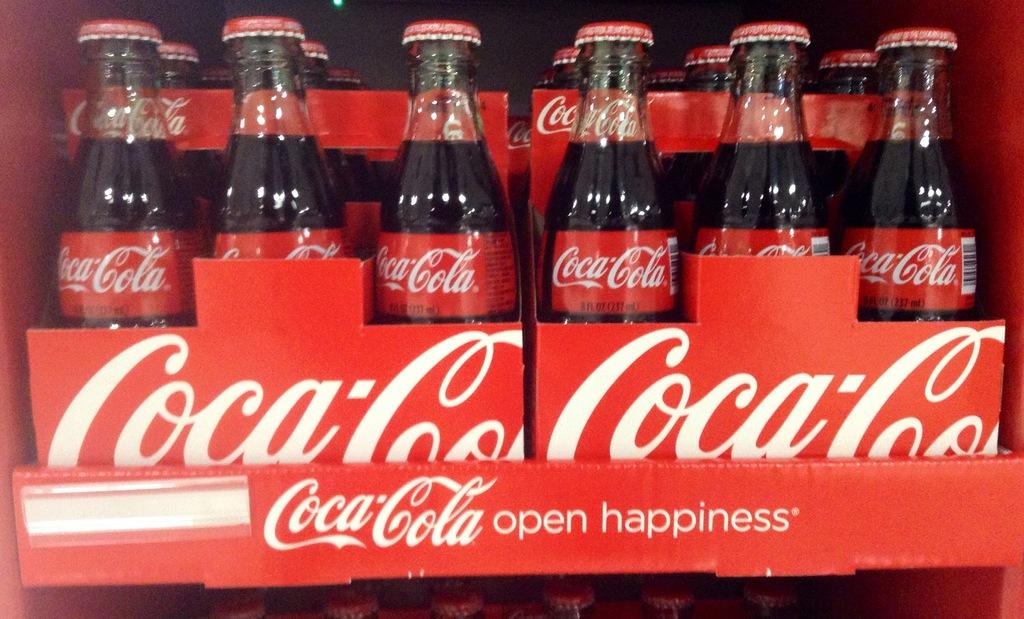What type of beverage bottles are present in the image? There are coca cola bottles in the image. What color are the coca cola bottles? The bottles are black in color. What other item related to coca cola can be seen in the image? There is a red coca cola box in the image. Are there any ants crawling on the coca cola bottles in the image? There is no mention of ants in the provided facts, so we cannot determine if there are any ants present in the image. 